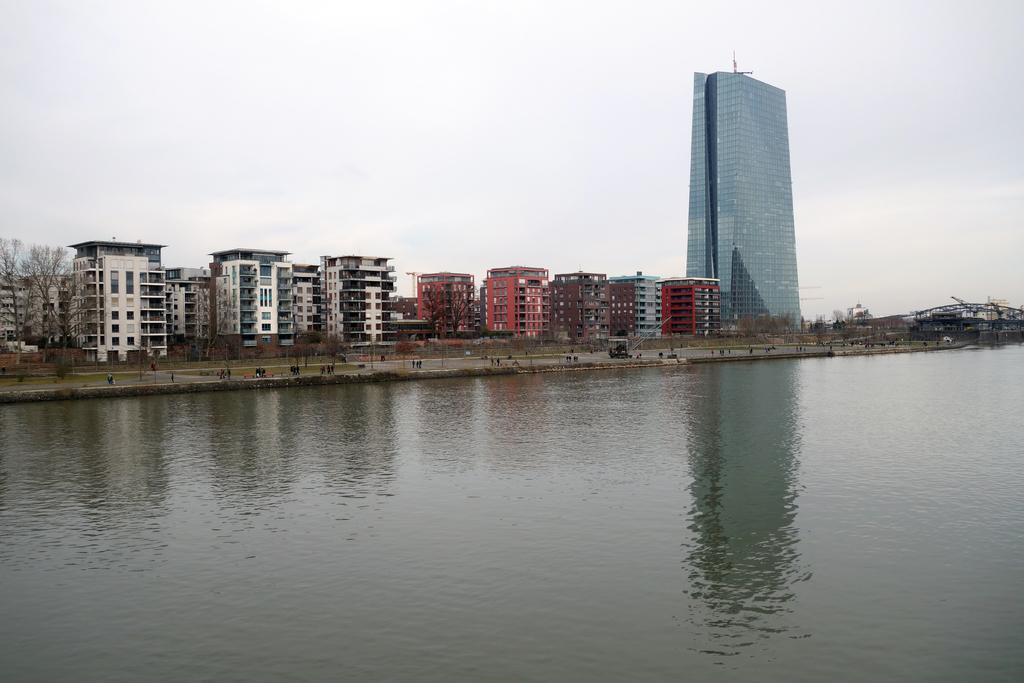What type of natural feature is present in the image? There is a sea in the image. What man-made structures can be seen in the image? There are buildings in the image. What type of vegetation is present in the image? There are trees in the image. What is visible at the top of the image? The sky is visible at the top of the image. Where is the sheet located in the image? There is no sheet present in the image. What type of drain is visible in the image? There is no drain present in the image. 